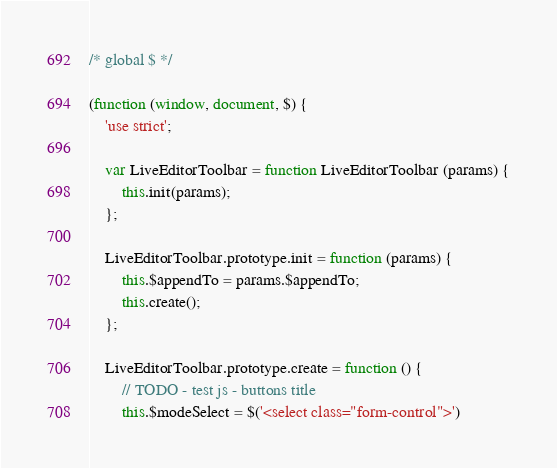Convert code to text. <code><loc_0><loc_0><loc_500><loc_500><_JavaScript_>/* global $ */

(function (window, document, $) {
    'use strict';

    var LiveEditorToolbar = function LiveEditorToolbar (params) {
        this.init(params);
    };

    LiveEditorToolbar.prototype.init = function (params) {
        this.$appendTo = params.$appendTo;
        this.create();
    };

    LiveEditorToolbar.prototype.create = function () {
        // TODO - test js - buttons title
        this.$modeSelect = $('<select class="form-control">')</code> 